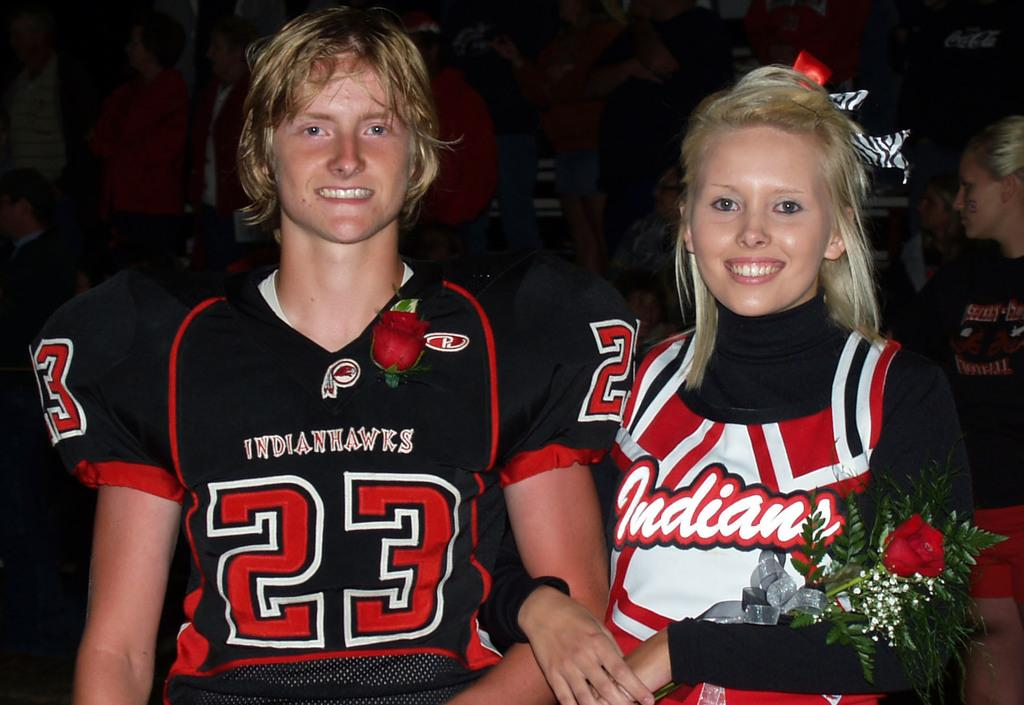<image>
Give a short and clear explanation of the subsequent image. Player number 23 stands next to an Indians cheerleader 